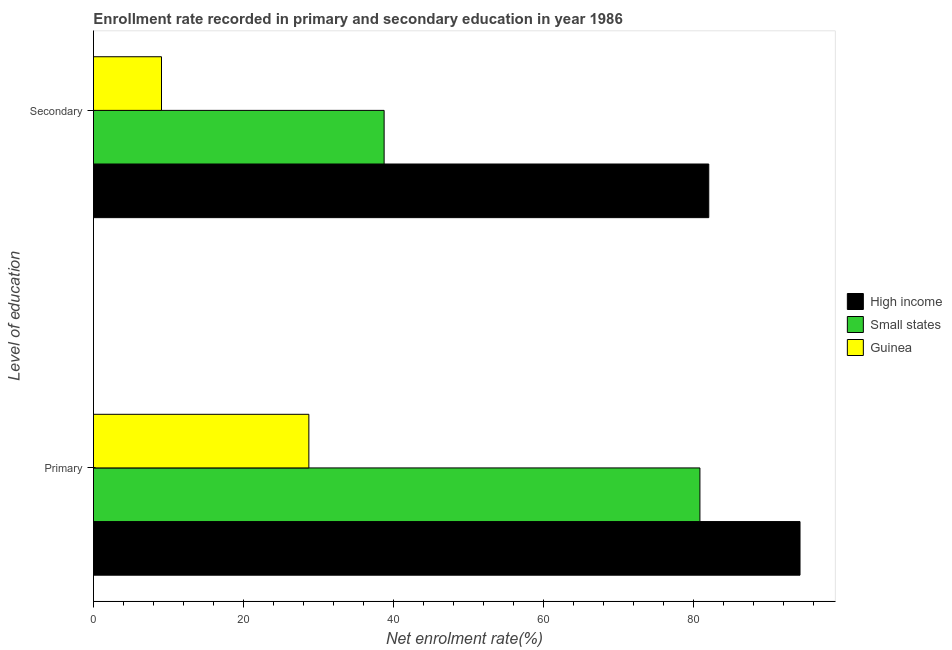How many different coloured bars are there?
Keep it short and to the point. 3. Are the number of bars on each tick of the Y-axis equal?
Provide a short and direct response. Yes. How many bars are there on the 1st tick from the top?
Give a very brief answer. 3. What is the label of the 1st group of bars from the top?
Offer a terse response. Secondary. What is the enrollment rate in secondary education in High income?
Your answer should be compact. 82.05. Across all countries, what is the maximum enrollment rate in primary education?
Give a very brief answer. 94.22. Across all countries, what is the minimum enrollment rate in primary education?
Ensure brevity in your answer.  28.72. In which country was the enrollment rate in secondary education maximum?
Offer a terse response. High income. In which country was the enrollment rate in primary education minimum?
Provide a short and direct response. Guinea. What is the total enrollment rate in primary education in the graph?
Give a very brief answer. 203.82. What is the difference between the enrollment rate in primary education in Guinea and that in High income?
Your answer should be compact. -65.5. What is the difference between the enrollment rate in secondary education in Guinea and the enrollment rate in primary education in High income?
Make the answer very short. -85.15. What is the average enrollment rate in primary education per country?
Ensure brevity in your answer.  67.94. What is the difference between the enrollment rate in primary education and enrollment rate in secondary education in Guinea?
Give a very brief answer. 19.65. In how many countries, is the enrollment rate in secondary education greater than 48 %?
Your response must be concise. 1. What is the ratio of the enrollment rate in primary education in Guinea to that in Small states?
Ensure brevity in your answer.  0.36. In how many countries, is the enrollment rate in secondary education greater than the average enrollment rate in secondary education taken over all countries?
Keep it short and to the point. 1. What does the 2nd bar from the top in Primary represents?
Your answer should be very brief. Small states. Are all the bars in the graph horizontal?
Offer a terse response. Yes. Does the graph contain any zero values?
Make the answer very short. No. What is the title of the graph?
Your answer should be compact. Enrollment rate recorded in primary and secondary education in year 1986. Does "France" appear as one of the legend labels in the graph?
Your answer should be very brief. No. What is the label or title of the X-axis?
Your response must be concise. Net enrolment rate(%). What is the label or title of the Y-axis?
Provide a succinct answer. Level of education. What is the Net enrolment rate(%) of High income in Primary?
Your response must be concise. 94.22. What is the Net enrolment rate(%) in Small states in Primary?
Give a very brief answer. 80.87. What is the Net enrolment rate(%) of Guinea in Primary?
Your response must be concise. 28.72. What is the Net enrolment rate(%) in High income in Secondary?
Give a very brief answer. 82.05. What is the Net enrolment rate(%) in Small states in Secondary?
Provide a succinct answer. 38.76. What is the Net enrolment rate(%) in Guinea in Secondary?
Your answer should be compact. 9.07. Across all Level of education, what is the maximum Net enrolment rate(%) of High income?
Make the answer very short. 94.22. Across all Level of education, what is the maximum Net enrolment rate(%) in Small states?
Provide a succinct answer. 80.87. Across all Level of education, what is the maximum Net enrolment rate(%) of Guinea?
Give a very brief answer. 28.72. Across all Level of education, what is the minimum Net enrolment rate(%) in High income?
Provide a short and direct response. 82.05. Across all Level of education, what is the minimum Net enrolment rate(%) of Small states?
Offer a very short reply. 38.76. Across all Level of education, what is the minimum Net enrolment rate(%) of Guinea?
Keep it short and to the point. 9.07. What is the total Net enrolment rate(%) in High income in the graph?
Your answer should be very brief. 176.27. What is the total Net enrolment rate(%) in Small states in the graph?
Offer a very short reply. 119.63. What is the total Net enrolment rate(%) of Guinea in the graph?
Make the answer very short. 37.8. What is the difference between the Net enrolment rate(%) in High income in Primary and that in Secondary?
Keep it short and to the point. 12.17. What is the difference between the Net enrolment rate(%) of Small states in Primary and that in Secondary?
Your answer should be very brief. 42.11. What is the difference between the Net enrolment rate(%) in Guinea in Primary and that in Secondary?
Offer a terse response. 19.65. What is the difference between the Net enrolment rate(%) of High income in Primary and the Net enrolment rate(%) of Small states in Secondary?
Provide a short and direct response. 55.46. What is the difference between the Net enrolment rate(%) of High income in Primary and the Net enrolment rate(%) of Guinea in Secondary?
Give a very brief answer. 85.15. What is the difference between the Net enrolment rate(%) of Small states in Primary and the Net enrolment rate(%) of Guinea in Secondary?
Make the answer very short. 71.8. What is the average Net enrolment rate(%) in High income per Level of education?
Your answer should be very brief. 88.14. What is the average Net enrolment rate(%) in Small states per Level of education?
Provide a succinct answer. 59.82. What is the average Net enrolment rate(%) in Guinea per Level of education?
Your response must be concise. 18.9. What is the difference between the Net enrolment rate(%) of High income and Net enrolment rate(%) of Small states in Primary?
Make the answer very short. 13.35. What is the difference between the Net enrolment rate(%) of High income and Net enrolment rate(%) of Guinea in Primary?
Give a very brief answer. 65.5. What is the difference between the Net enrolment rate(%) of Small states and Net enrolment rate(%) of Guinea in Primary?
Make the answer very short. 52.15. What is the difference between the Net enrolment rate(%) of High income and Net enrolment rate(%) of Small states in Secondary?
Provide a succinct answer. 43.29. What is the difference between the Net enrolment rate(%) of High income and Net enrolment rate(%) of Guinea in Secondary?
Your response must be concise. 72.98. What is the difference between the Net enrolment rate(%) in Small states and Net enrolment rate(%) in Guinea in Secondary?
Your response must be concise. 29.69. What is the ratio of the Net enrolment rate(%) in High income in Primary to that in Secondary?
Provide a short and direct response. 1.15. What is the ratio of the Net enrolment rate(%) of Small states in Primary to that in Secondary?
Offer a very short reply. 2.09. What is the ratio of the Net enrolment rate(%) in Guinea in Primary to that in Secondary?
Offer a very short reply. 3.17. What is the difference between the highest and the second highest Net enrolment rate(%) in High income?
Keep it short and to the point. 12.17. What is the difference between the highest and the second highest Net enrolment rate(%) of Small states?
Ensure brevity in your answer.  42.11. What is the difference between the highest and the second highest Net enrolment rate(%) in Guinea?
Give a very brief answer. 19.65. What is the difference between the highest and the lowest Net enrolment rate(%) in High income?
Provide a short and direct response. 12.17. What is the difference between the highest and the lowest Net enrolment rate(%) of Small states?
Ensure brevity in your answer.  42.11. What is the difference between the highest and the lowest Net enrolment rate(%) in Guinea?
Your response must be concise. 19.65. 